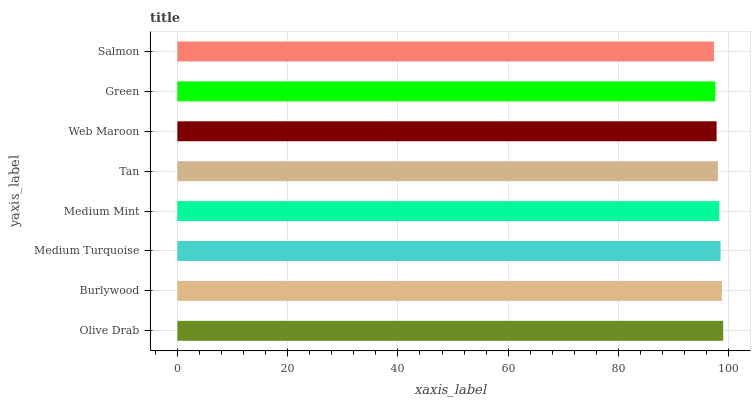Is Salmon the minimum?
Answer yes or no. Yes. Is Olive Drab the maximum?
Answer yes or no. Yes. Is Burlywood the minimum?
Answer yes or no. No. Is Burlywood the maximum?
Answer yes or no. No. Is Olive Drab greater than Burlywood?
Answer yes or no. Yes. Is Burlywood less than Olive Drab?
Answer yes or no. Yes. Is Burlywood greater than Olive Drab?
Answer yes or no. No. Is Olive Drab less than Burlywood?
Answer yes or no. No. Is Medium Mint the high median?
Answer yes or no. Yes. Is Tan the low median?
Answer yes or no. Yes. Is Green the high median?
Answer yes or no. No. Is Medium Turquoise the low median?
Answer yes or no. No. 